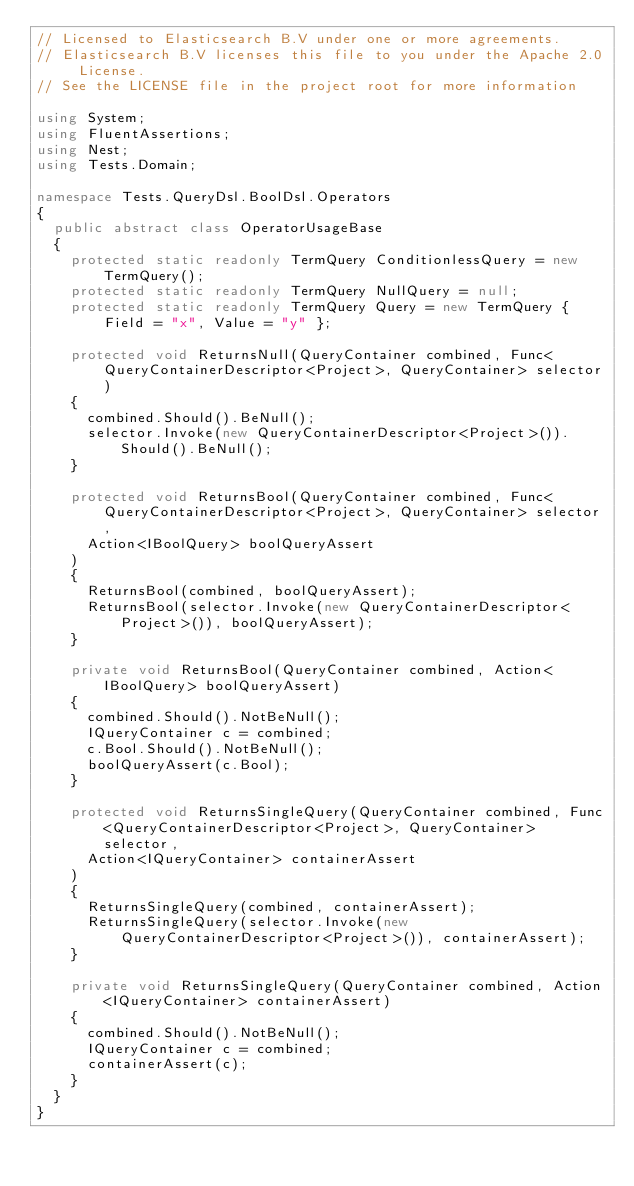Convert code to text. <code><loc_0><loc_0><loc_500><loc_500><_C#_>// Licensed to Elasticsearch B.V under one or more agreements.
// Elasticsearch B.V licenses this file to you under the Apache 2.0 License.
// See the LICENSE file in the project root for more information

using System;
using FluentAssertions;
using Nest;
using Tests.Domain;

namespace Tests.QueryDsl.BoolDsl.Operators
{
	public abstract class OperatorUsageBase
	{
		protected static readonly TermQuery ConditionlessQuery = new TermQuery();
		protected static readonly TermQuery NullQuery = null;
		protected static readonly TermQuery Query = new TermQuery { Field = "x", Value = "y" };

		protected void ReturnsNull(QueryContainer combined, Func<QueryContainerDescriptor<Project>, QueryContainer> selector)
		{
			combined.Should().BeNull();
			selector.Invoke(new QueryContainerDescriptor<Project>()).Should().BeNull();
		}

		protected void ReturnsBool(QueryContainer combined, Func<QueryContainerDescriptor<Project>, QueryContainer> selector,
			Action<IBoolQuery> boolQueryAssert
		)
		{
			ReturnsBool(combined, boolQueryAssert);
			ReturnsBool(selector.Invoke(new QueryContainerDescriptor<Project>()), boolQueryAssert);
		}

		private void ReturnsBool(QueryContainer combined, Action<IBoolQuery> boolQueryAssert)
		{
			combined.Should().NotBeNull();
			IQueryContainer c = combined;
			c.Bool.Should().NotBeNull();
			boolQueryAssert(c.Bool);
		}

		protected void ReturnsSingleQuery(QueryContainer combined, Func<QueryContainerDescriptor<Project>, QueryContainer> selector,
			Action<IQueryContainer> containerAssert
		)
		{
			ReturnsSingleQuery(combined, containerAssert);
			ReturnsSingleQuery(selector.Invoke(new QueryContainerDescriptor<Project>()), containerAssert);
		}

		private void ReturnsSingleQuery(QueryContainer combined, Action<IQueryContainer> containerAssert)
		{
			combined.Should().NotBeNull();
			IQueryContainer c = combined;
			containerAssert(c);
		}
	}
}
</code> 